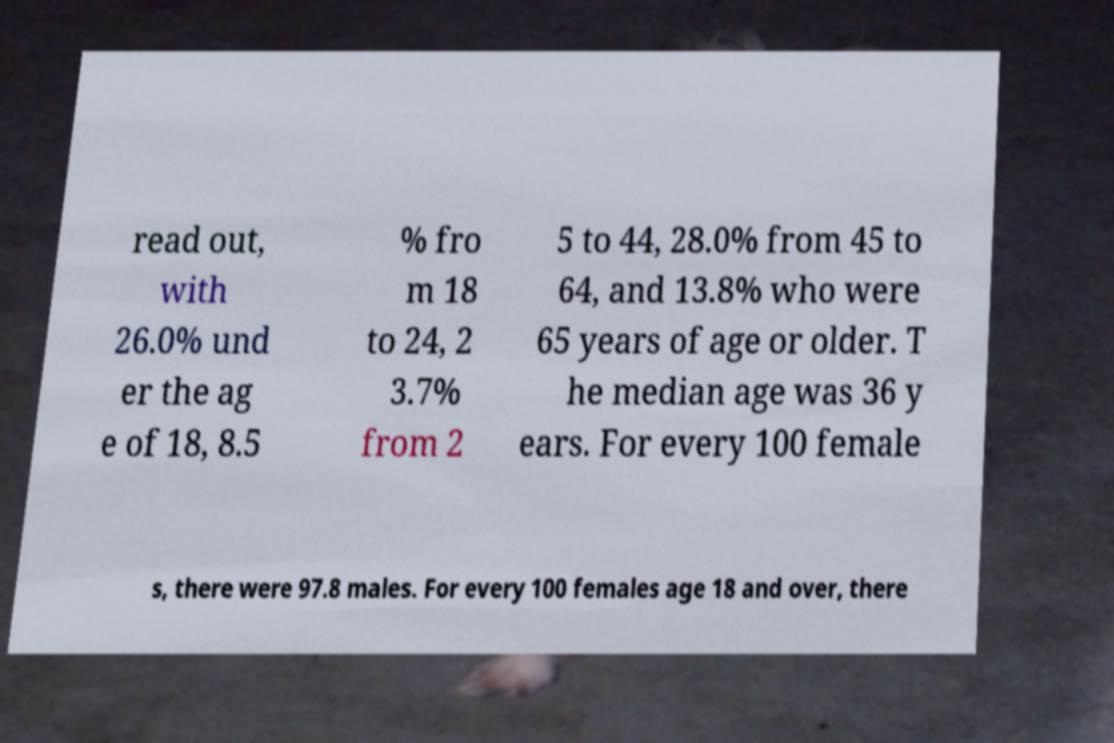There's text embedded in this image that I need extracted. Can you transcribe it verbatim? read out, with 26.0% und er the ag e of 18, 8.5 % fro m 18 to 24, 2 3.7% from 2 5 to 44, 28.0% from 45 to 64, and 13.8% who were 65 years of age or older. T he median age was 36 y ears. For every 100 female s, there were 97.8 males. For every 100 females age 18 and over, there 